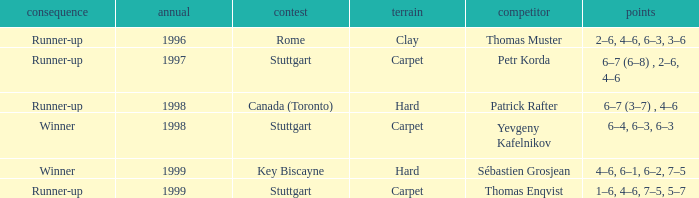What was the outcome before 1997? Runner-up. 